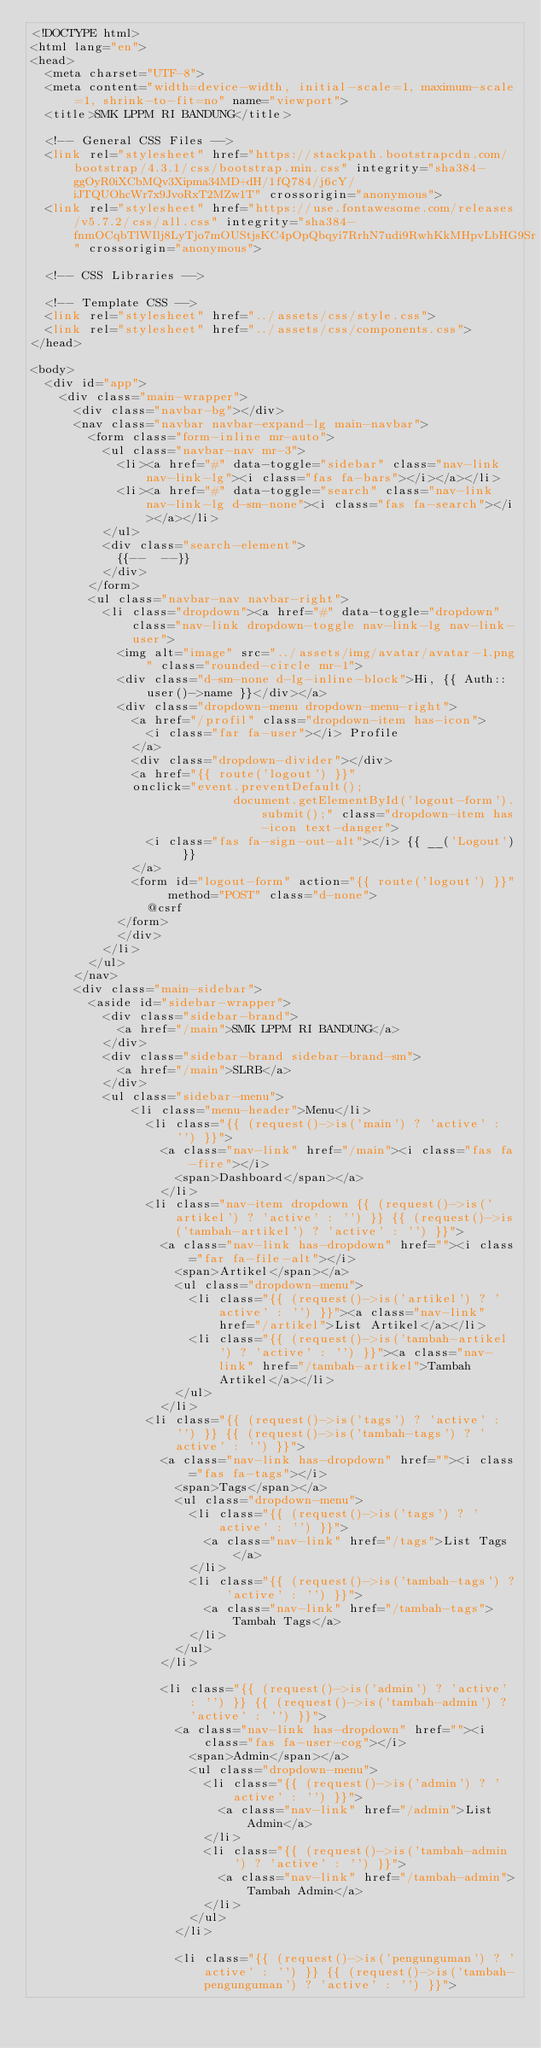<code> <loc_0><loc_0><loc_500><loc_500><_PHP_><!DOCTYPE html>
<html lang="en">
<head>
  <meta charset="UTF-8">
  <meta content="width=device-width, initial-scale=1, maximum-scale=1, shrink-to-fit=no" name="viewport">
  <title>SMK LPPM RI BANDUNG</title>

  <!-- General CSS Files -->
  <link rel="stylesheet" href="https://stackpath.bootstrapcdn.com/bootstrap/4.3.1/css/bootstrap.min.css" integrity="sha384-ggOyR0iXCbMQv3Xipma34MD+dH/1fQ784/j6cY/iJTQUOhcWr7x9JvoRxT2MZw1T" crossorigin="anonymous">
  <link rel="stylesheet" href="https://use.fontawesome.com/releases/v5.7.2/css/all.css" integrity="sha384-fnmOCqbTlWIlj8LyTjo7mOUStjsKC4pOpQbqyi7RrhN7udi9RwhKkMHpvLbHG9Sr" crossorigin="anonymous">

  <!-- CSS Libraries -->

  <!-- Template CSS -->
  <link rel="stylesheet" href="../assets/css/style.css">
  <link rel="stylesheet" href="../assets/css/components.css">
</head>

<body>
  <div id="app">
    <div class="main-wrapper">
      <div class="navbar-bg"></div>
      <nav class="navbar navbar-expand-lg main-navbar">
        <form class="form-inline mr-auto">
          <ul class="navbar-nav mr-3">
            <li><a href="#" data-toggle="sidebar" class="nav-link nav-link-lg"><i class="fas fa-bars"></i></a></li>
            <li><a href="#" data-toggle="search" class="nav-link nav-link-lg d-sm-none"><i class="fas fa-search"></i></a></li>
          </ul>
          <div class="search-element">
            {{--  --}}
          </div>
        </form>
        <ul class="navbar-nav navbar-right">
          <li class="dropdown"><a href="#" data-toggle="dropdown" class="nav-link dropdown-toggle nav-link-lg nav-link-user">
            <img alt="image" src="../assets/img/avatar/avatar-1.png" class="rounded-circle mr-1">
            <div class="d-sm-none d-lg-inline-block">Hi, {{ Auth::user()->name }}</div></a>
            <div class="dropdown-menu dropdown-menu-right">
              <a href="/profil" class="dropdown-item has-icon">
                <i class="far fa-user"></i> Profile
              </a>
              <div class="dropdown-divider"></div>
              <a href="{{ route('logout') }}"
              onclick="event.preventDefault();
                            document.getElementById('logout-form').submit();" class="dropdown-item has-icon text-danger">
                <i class="fas fa-sign-out-alt"></i> {{ __('Logout') }}
              </a>
              <form id="logout-form" action="{{ route('logout') }}" method="POST" class="d-none">
                @csrf
            </form>
            </div>
          </li>
        </ul>
      </nav>
      <div class="main-sidebar">
        <aside id="sidebar-wrapper">
          <div class="sidebar-brand">
            <a href="/main">SMK LPPM RI BANDUNG</a>
          </div>
          <div class="sidebar-brand sidebar-brand-sm">
            <a href="/main">SLRB</a>
          </div>
          <ul class="sidebar-menu">
              <li class="menu-header">Menu</li>
                <li class="{{ (request()->is('main') ? 'active' : '') }}">
                  <a class="nav-link" href="/main"><i class="fas fa-fire"></i> 
                    <span>Dashboard</span></a>
                  </li>
                <li class="nav-item dropdown {{ (request()->is('artikel') ? 'active' : '') }} {{ (request()->is('tambah-artikel') ? 'active' : '') }}">
                  <a class="nav-link has-dropdown" href=""><i class="far fa-file-alt"></i> 
                    <span>Artikel</span></a>
                    <ul class="dropdown-menu">
                      <li class="{{ (request()->is('artikel') ? 'active' : '') }}"><a class="nav-link" href="/artikel">List Artikel</a></li>
                      <li class="{{ (request()->is('tambah-artikel') ? 'active' : '') }}"><a class="nav-link" href="/tambah-artikel">Tambah Artikel</a></li>
                    </ul>
                  </li>
                <li class="{{ (request()->is('tags') ? 'active' : '') }} {{ (request()->is('tambah-tags') ? 'active' : '') }}">
                  <a class="nav-link has-dropdown" href=""><i class="fas fa-tags"></i> 
                    <span>Tags</span></a>
                    <ul class="dropdown-menu">
                      <li class="{{ (request()->is('tags') ? 'active' : '') }}">
                        <a class="nav-link" href="/tags">List Tags</a>
                      </li>
                      <li class="{{ (request()->is('tambah-tags') ? 'active' : '') }}">
                        <a class="nav-link" href="/tambah-tags">Tambah Tags</a>
                      </li>
                    </ul>
                  </li>

                  <li class="{{ (request()->is('admin') ? 'active' : '') }} {{ (request()->is('tambah-admin') ? 'active' : '') }}">
                    <a class="nav-link has-dropdown" href=""><i class="fas fa-user-cog"></i> 
                      <span>Admin</span></a>
                      <ul class="dropdown-menu">
                        <li class="{{ (request()->is('admin') ? 'active' : '') }}">
                          <a class="nav-link" href="/admin">List Admin</a>
                        </li>
                        <li class="{{ (request()->is('tambah-admin') ? 'active' : '') }}">
                          <a class="nav-link" href="/tambah-admin">Tambah Admin</a>
                        </li>
                      </ul>
                    </li>

                    <li class="{{ (request()->is('pengunguman') ? 'active' : '') }} {{ (request()->is('tambah-pengunguman') ? 'active' : '') }}"></code> 